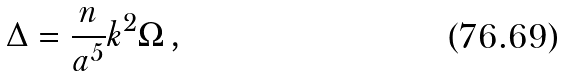<formula> <loc_0><loc_0><loc_500><loc_500>\Delta = { \frac { n } { a ^ { 5 } } } k ^ { 2 } \Omega \, ,</formula> 